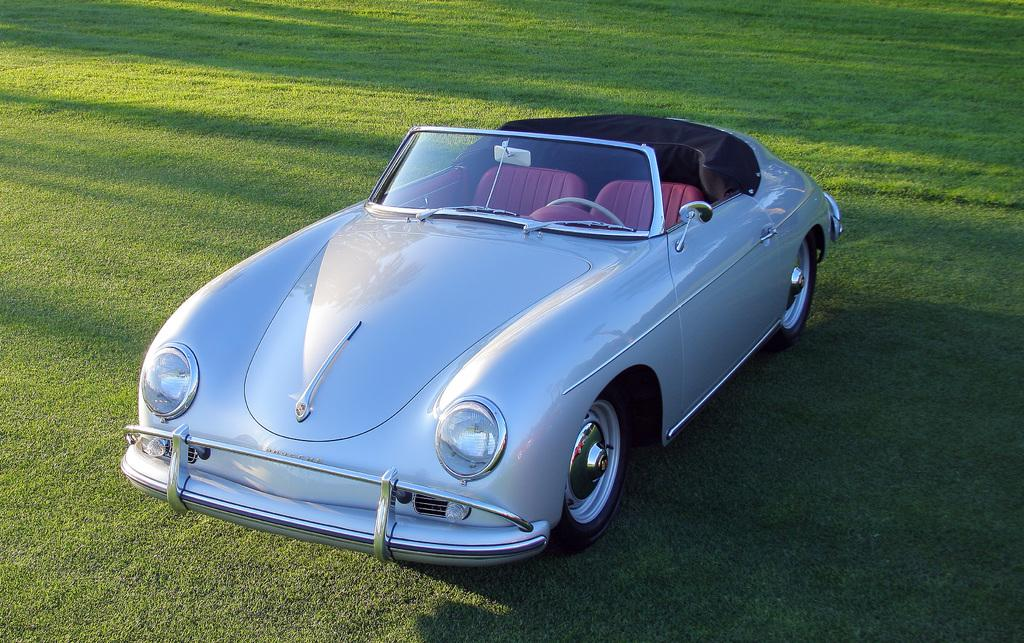What is the main subject of the image? The main subject of the image is a car. Where is the car located in the image? The car is on the grass. What type of oven can be seen in the image? There is no oven present in the image; it features a car on the grass. What type of goat is standing near the car in the image? There is no goat present in the image; it only features a car on the grass. 